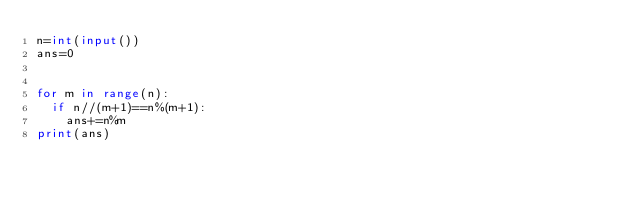<code> <loc_0><loc_0><loc_500><loc_500><_Python_>n=int(input())
ans=0


for m in range(n):
  if n//(m+1)==n%(m+1):
    ans+=n%m
print(ans)   </code> 